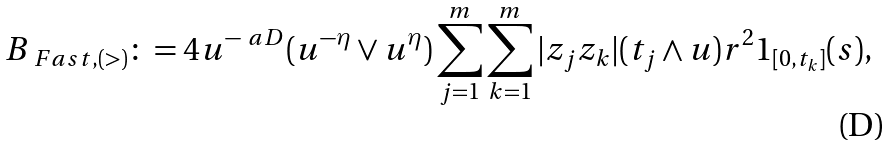<formula> <loc_0><loc_0><loc_500><loc_500>B _ { \ F a s t , ( > ) } \colon = 4 u ^ { - \ a D } ( u ^ { - \eta } \vee u ^ { \eta } ) \sum _ { j = 1 } ^ { m } \sum _ { k = 1 } ^ { m } | z _ { j } z _ { k } | ( t _ { j } \wedge u ) r ^ { 2 } 1 _ { [ 0 , t _ { k } ] } ( s ) ,</formula> 